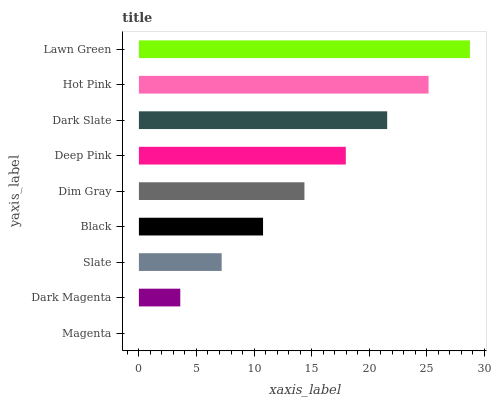Is Magenta the minimum?
Answer yes or no. Yes. Is Lawn Green the maximum?
Answer yes or no. Yes. Is Dark Magenta the minimum?
Answer yes or no. No. Is Dark Magenta the maximum?
Answer yes or no. No. Is Dark Magenta greater than Magenta?
Answer yes or no. Yes. Is Magenta less than Dark Magenta?
Answer yes or no. Yes. Is Magenta greater than Dark Magenta?
Answer yes or no. No. Is Dark Magenta less than Magenta?
Answer yes or no. No. Is Dim Gray the high median?
Answer yes or no. Yes. Is Dim Gray the low median?
Answer yes or no. Yes. Is Hot Pink the high median?
Answer yes or no. No. Is Magenta the low median?
Answer yes or no. No. 